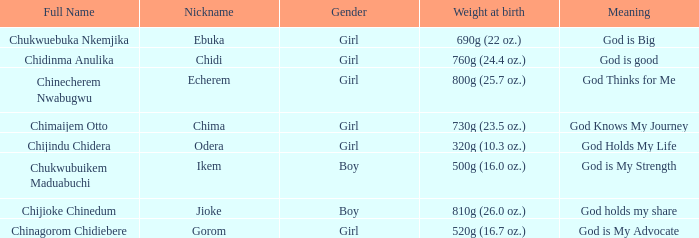How much did the girl, nicknamed Chidi, weigh at birth? 760g (24.4 oz.). 